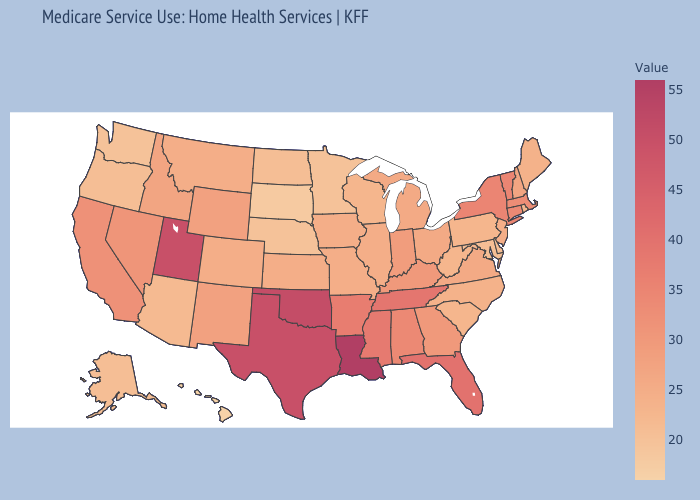Does Mississippi have a lower value than Idaho?
Answer briefly. No. Among the states that border South Carolina , which have the highest value?
Write a very short answer. Georgia. Which states have the lowest value in the USA?
Keep it brief. Hawaii. Does Hawaii have the lowest value in the USA?
Give a very brief answer. Yes. Among the states that border Georgia , does South Carolina have the lowest value?
Give a very brief answer. Yes. Among the states that border Wyoming , does South Dakota have the lowest value?
Keep it brief. Yes. Does Arizona have the highest value in the West?
Keep it brief. No. Is the legend a continuous bar?
Quick response, please. Yes. 